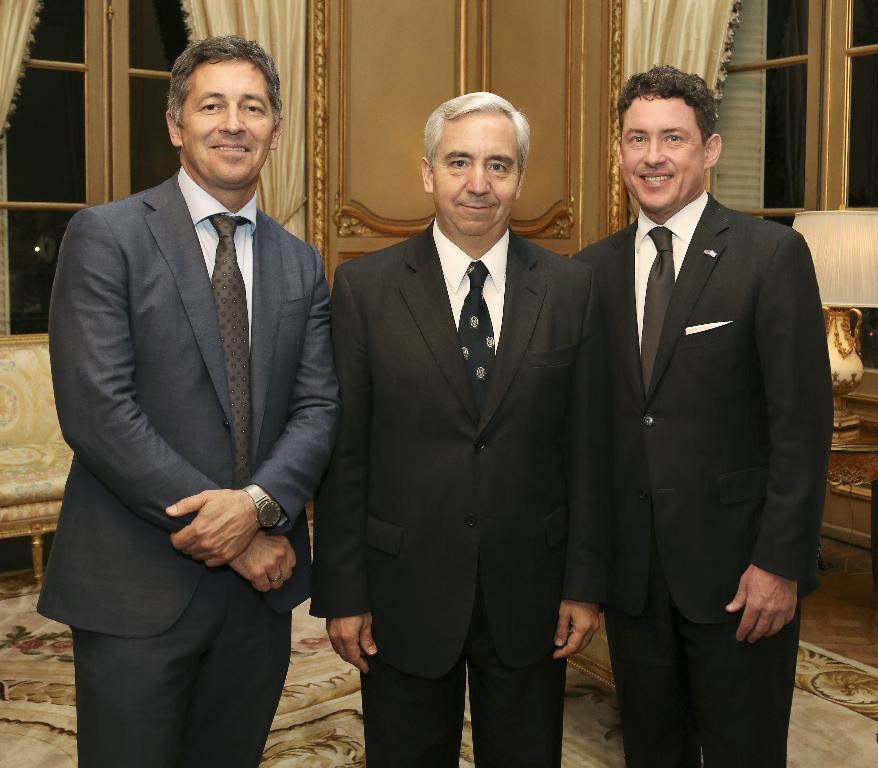Can you describe this image briefly? In this picture we can see three persons standing in the middle. All are wearing suits. and he wear a watch. And on the background there is a sofa. This is the table. These are the windows and there is a curtain. This is the floor and there is a door. 